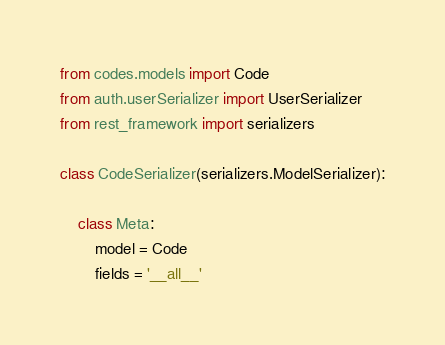<code> <loc_0><loc_0><loc_500><loc_500><_Python_>from codes.models import Code
from auth.userSerializer import UserSerializer
from rest_framework import serializers

class CodeSerializer(serializers.ModelSerializer):

    class Meta:
        model = Code
        fields = '__all__'</code> 